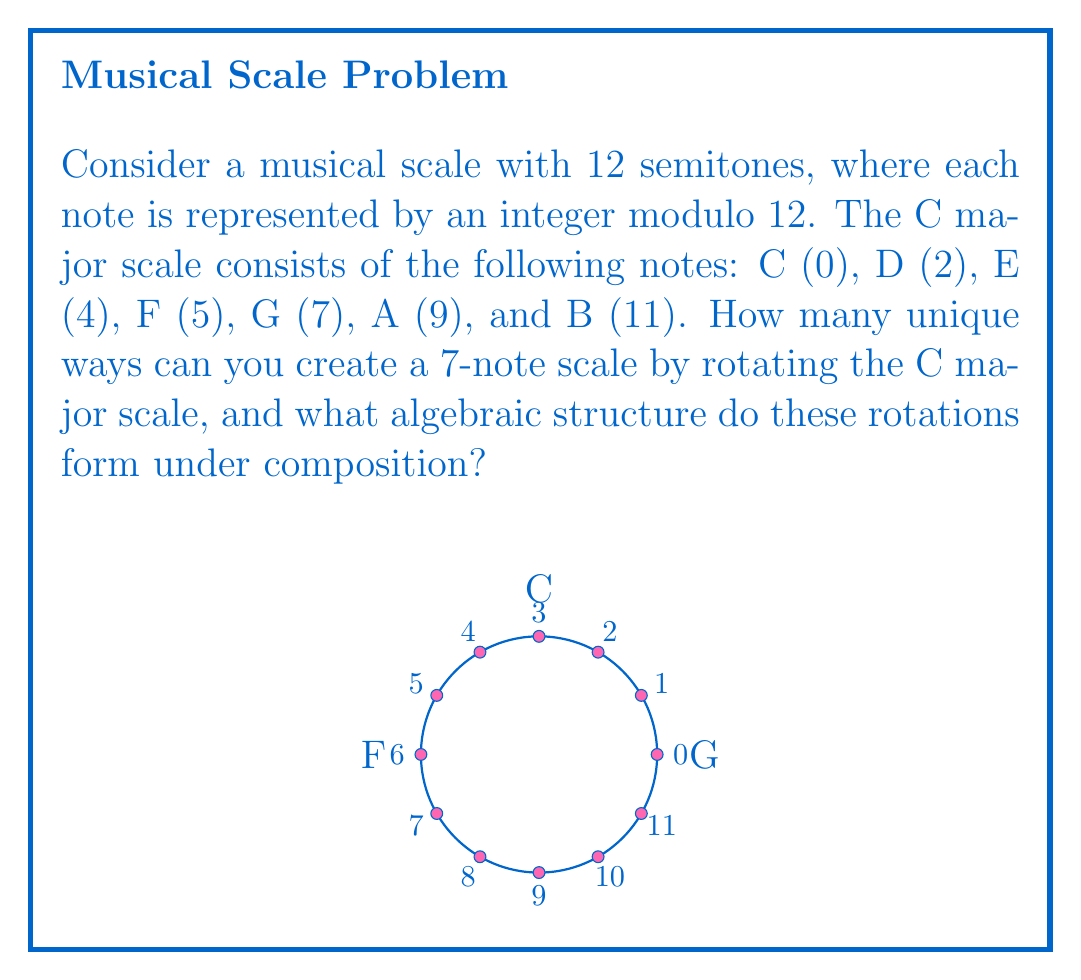Show me your answer to this math problem. Let's approach this step-by-step:

1) First, we need to understand what a rotation of the scale means. It's equivalent to starting the scale on a different note but keeping the same interval pattern. For example, rotating by 2 semitones gives: D (2), E (4), F♯ (6), G (7), A (9), B (11), C♯ (1).

2) Mathematically, we can represent this rotation as an operation on the set of integers modulo 12. Let $r_k$ represent a rotation by $k$ semitones. Then:

   $r_k(x) = (x + k) \bmod 12$

3) The question asks how many unique 7-note scales we can create this way. This is equivalent to asking how many unique rotations exist.

4) There are 12 possible rotations (including the identity rotation), corresponding to the 12 semitones. However, some of these might produce the same scale.

5) Two rotations produce the same scale if and only if they differ by a multiple of 12. Since our scale has 7 notes, rotations that differ by 7, 14, 21, etc. semitones will produce the same scale.

6) Therefore, the number of unique scales is $12 / \gcd(12, 7) = 12 / 1 = 12$.

7) Now, let's consider the algebraic structure formed by these rotations under composition. 

   - The set of rotations is closed under composition: $r_j \circ r_k = r_{(j+k) \bmod 12}$
   - Composition is associative
   - The identity element is $r_0$
   - Each rotation has an inverse: $(r_k)^{-1} = r_{12-k}$

8) These properties define a cyclic group of order 12, which is isomorphic to $\mathbb{Z}_{12}$ under addition.

9) In ring theory, we can consider this group along with an additional operation. If we define "multiplication" of rotations as $r_j * r_k = r_{jk \bmod 12}$, we get a ring structure.

10) This ring is isomorphic to $\mathbb{Z}_{12}$ with its usual addition and multiplication operations.
Answer: 12 unique scales; rotations form a cyclic group of order 12, isomorphic to $(\mathbb{Z}_{12}, +)$, which can be extended to a ring isomorphic to $(\mathbb{Z}_{12}, +, \cdot)$. 